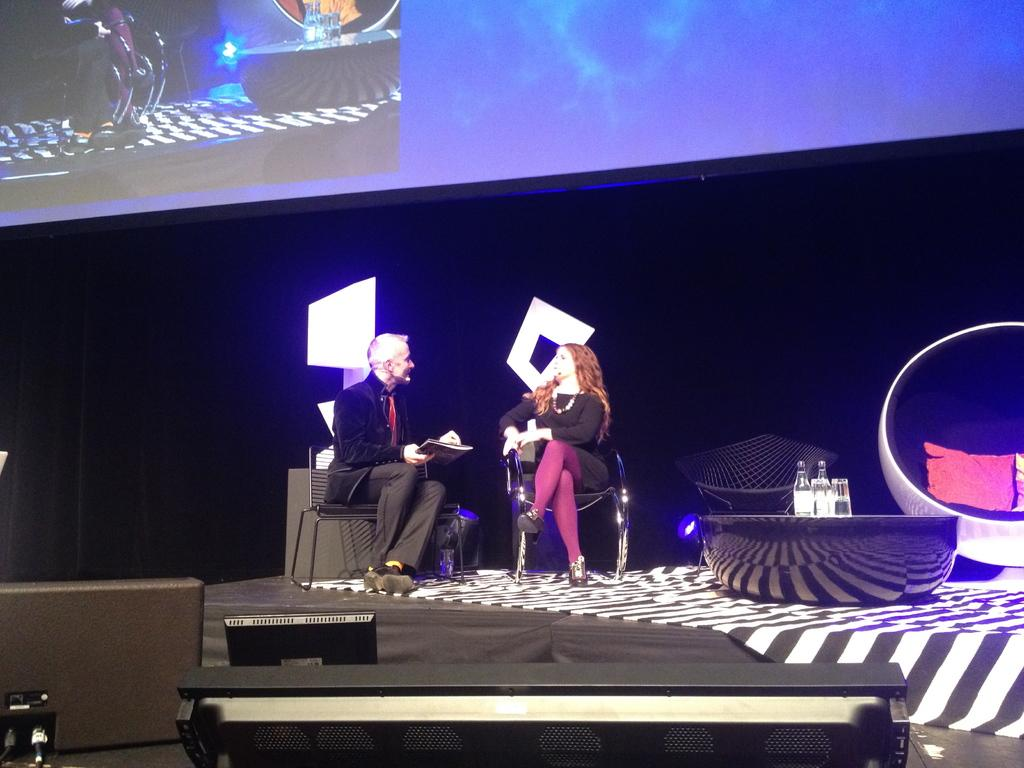What is happening on the stage in the image? There are people sitting on the stage in the image. What can be seen at the top side of the image? There is a screen at the top side of the image. What is present at the bottom side of the image? There are some objects at the bottom side of the image. What type of alarm is going off in the image? There is no alarm present in the image. What can be seen from the edge of the stage in the image? The provided facts do not mention an edge of the stage or any specific view from it, so we cannot answer this question definitively. 